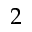<formula> <loc_0><loc_0><loc_500><loc_500>2</formula> 